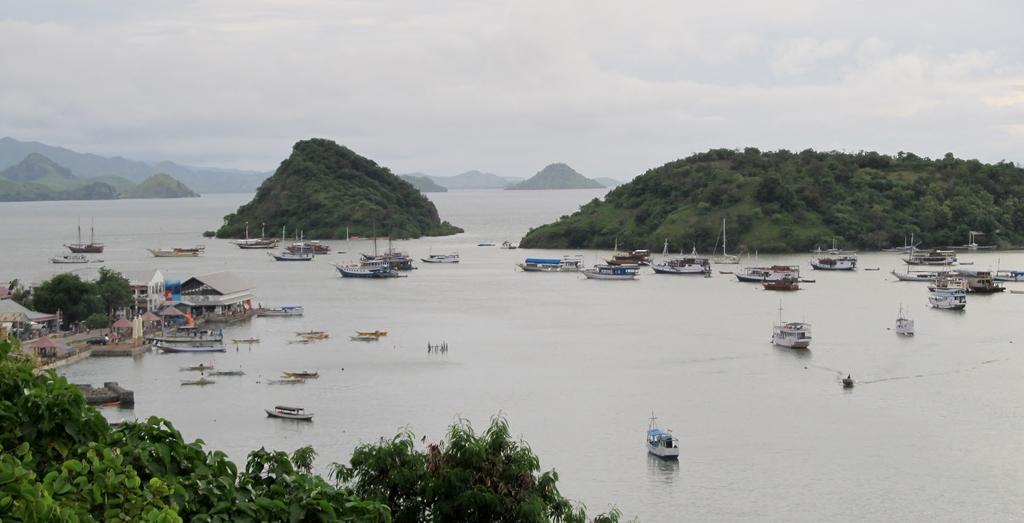In one or two sentences, can you explain what this image depicts? Here in this picture we can see a river present and we can see number of boats present in the river and in the front we can see trees present and on the left side we can see a shed and a building present and we can also see mountains present in the middle of the river, that are covered with grass, plants and we can see the sky is fully covered with clouds. 